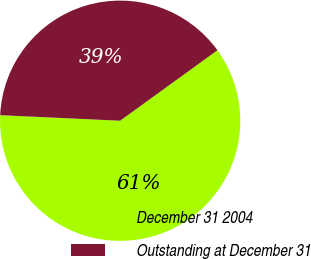Convert chart. <chart><loc_0><loc_0><loc_500><loc_500><pie_chart><fcel>December 31 2004<fcel>Outstanding at December 31<nl><fcel>60.71%<fcel>39.29%<nl></chart> 